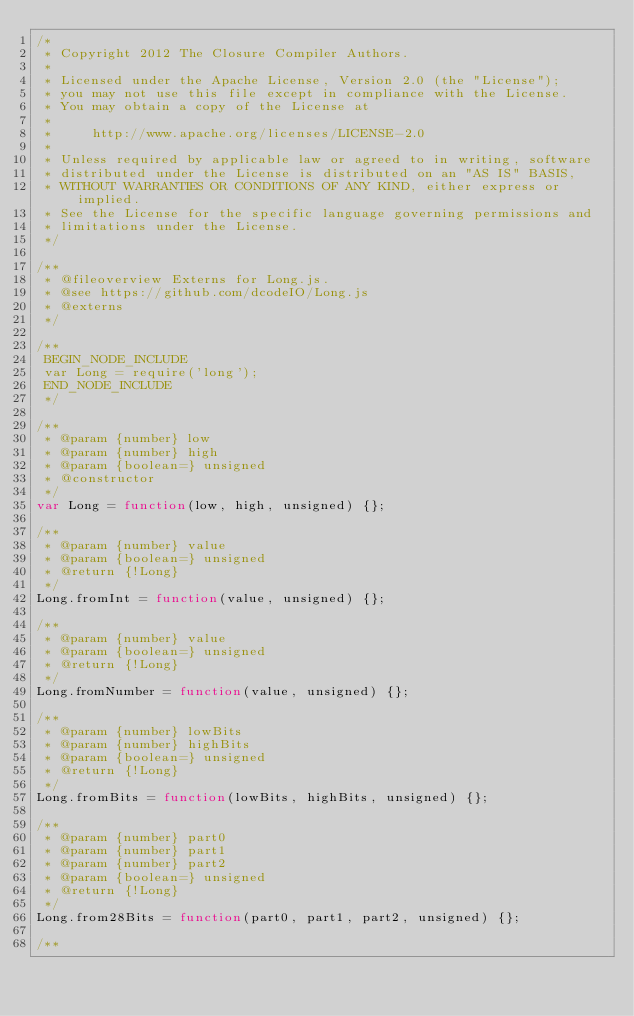<code> <loc_0><loc_0><loc_500><loc_500><_JavaScript_>/*
 * Copyright 2012 The Closure Compiler Authors.
 *
 * Licensed under the Apache License, Version 2.0 (the "License");
 * you may not use this file except in compliance with the License.
 * You may obtain a copy of the License at
 *
 *     http://www.apache.org/licenses/LICENSE-2.0
 *
 * Unless required by applicable law or agreed to in writing, software
 * distributed under the License is distributed on an "AS IS" BASIS,
 * WITHOUT WARRANTIES OR CONDITIONS OF ANY KIND, either express or implied.
 * See the License for the specific language governing permissions and
 * limitations under the License.
 */

/**
 * @fileoverview Externs for Long.js.
 * @see https://github.com/dcodeIO/Long.js
 * @externs
 */

/**
 BEGIN_NODE_INCLUDE
 var Long = require('long');
 END_NODE_INCLUDE
 */

/**
 * @param {number} low
 * @param {number} high
 * @param {boolean=} unsigned
 * @constructor
 */
var Long = function(low, high, unsigned) {};

/**
 * @param {number} value
 * @param {boolean=} unsigned
 * @return {!Long}
 */
Long.fromInt = function(value, unsigned) {};

/**
 * @param {number} value
 * @param {boolean=} unsigned
 * @return {!Long}
 */
Long.fromNumber = function(value, unsigned) {};

/**
 * @param {number} lowBits
 * @param {number} highBits
 * @param {boolean=} unsigned
 * @return {!Long}
 */
Long.fromBits = function(lowBits, highBits, unsigned) {};

/**
 * @param {number} part0
 * @param {number} part1
 * @param {number} part2
 * @param {boolean=} unsigned
 * @return {!Long}
 */
Long.from28Bits = function(part0, part1, part2, unsigned) {};

/**</code> 